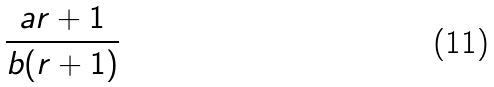<formula> <loc_0><loc_0><loc_500><loc_500>\frac { a r + 1 } { b ( r + 1 ) }</formula> 